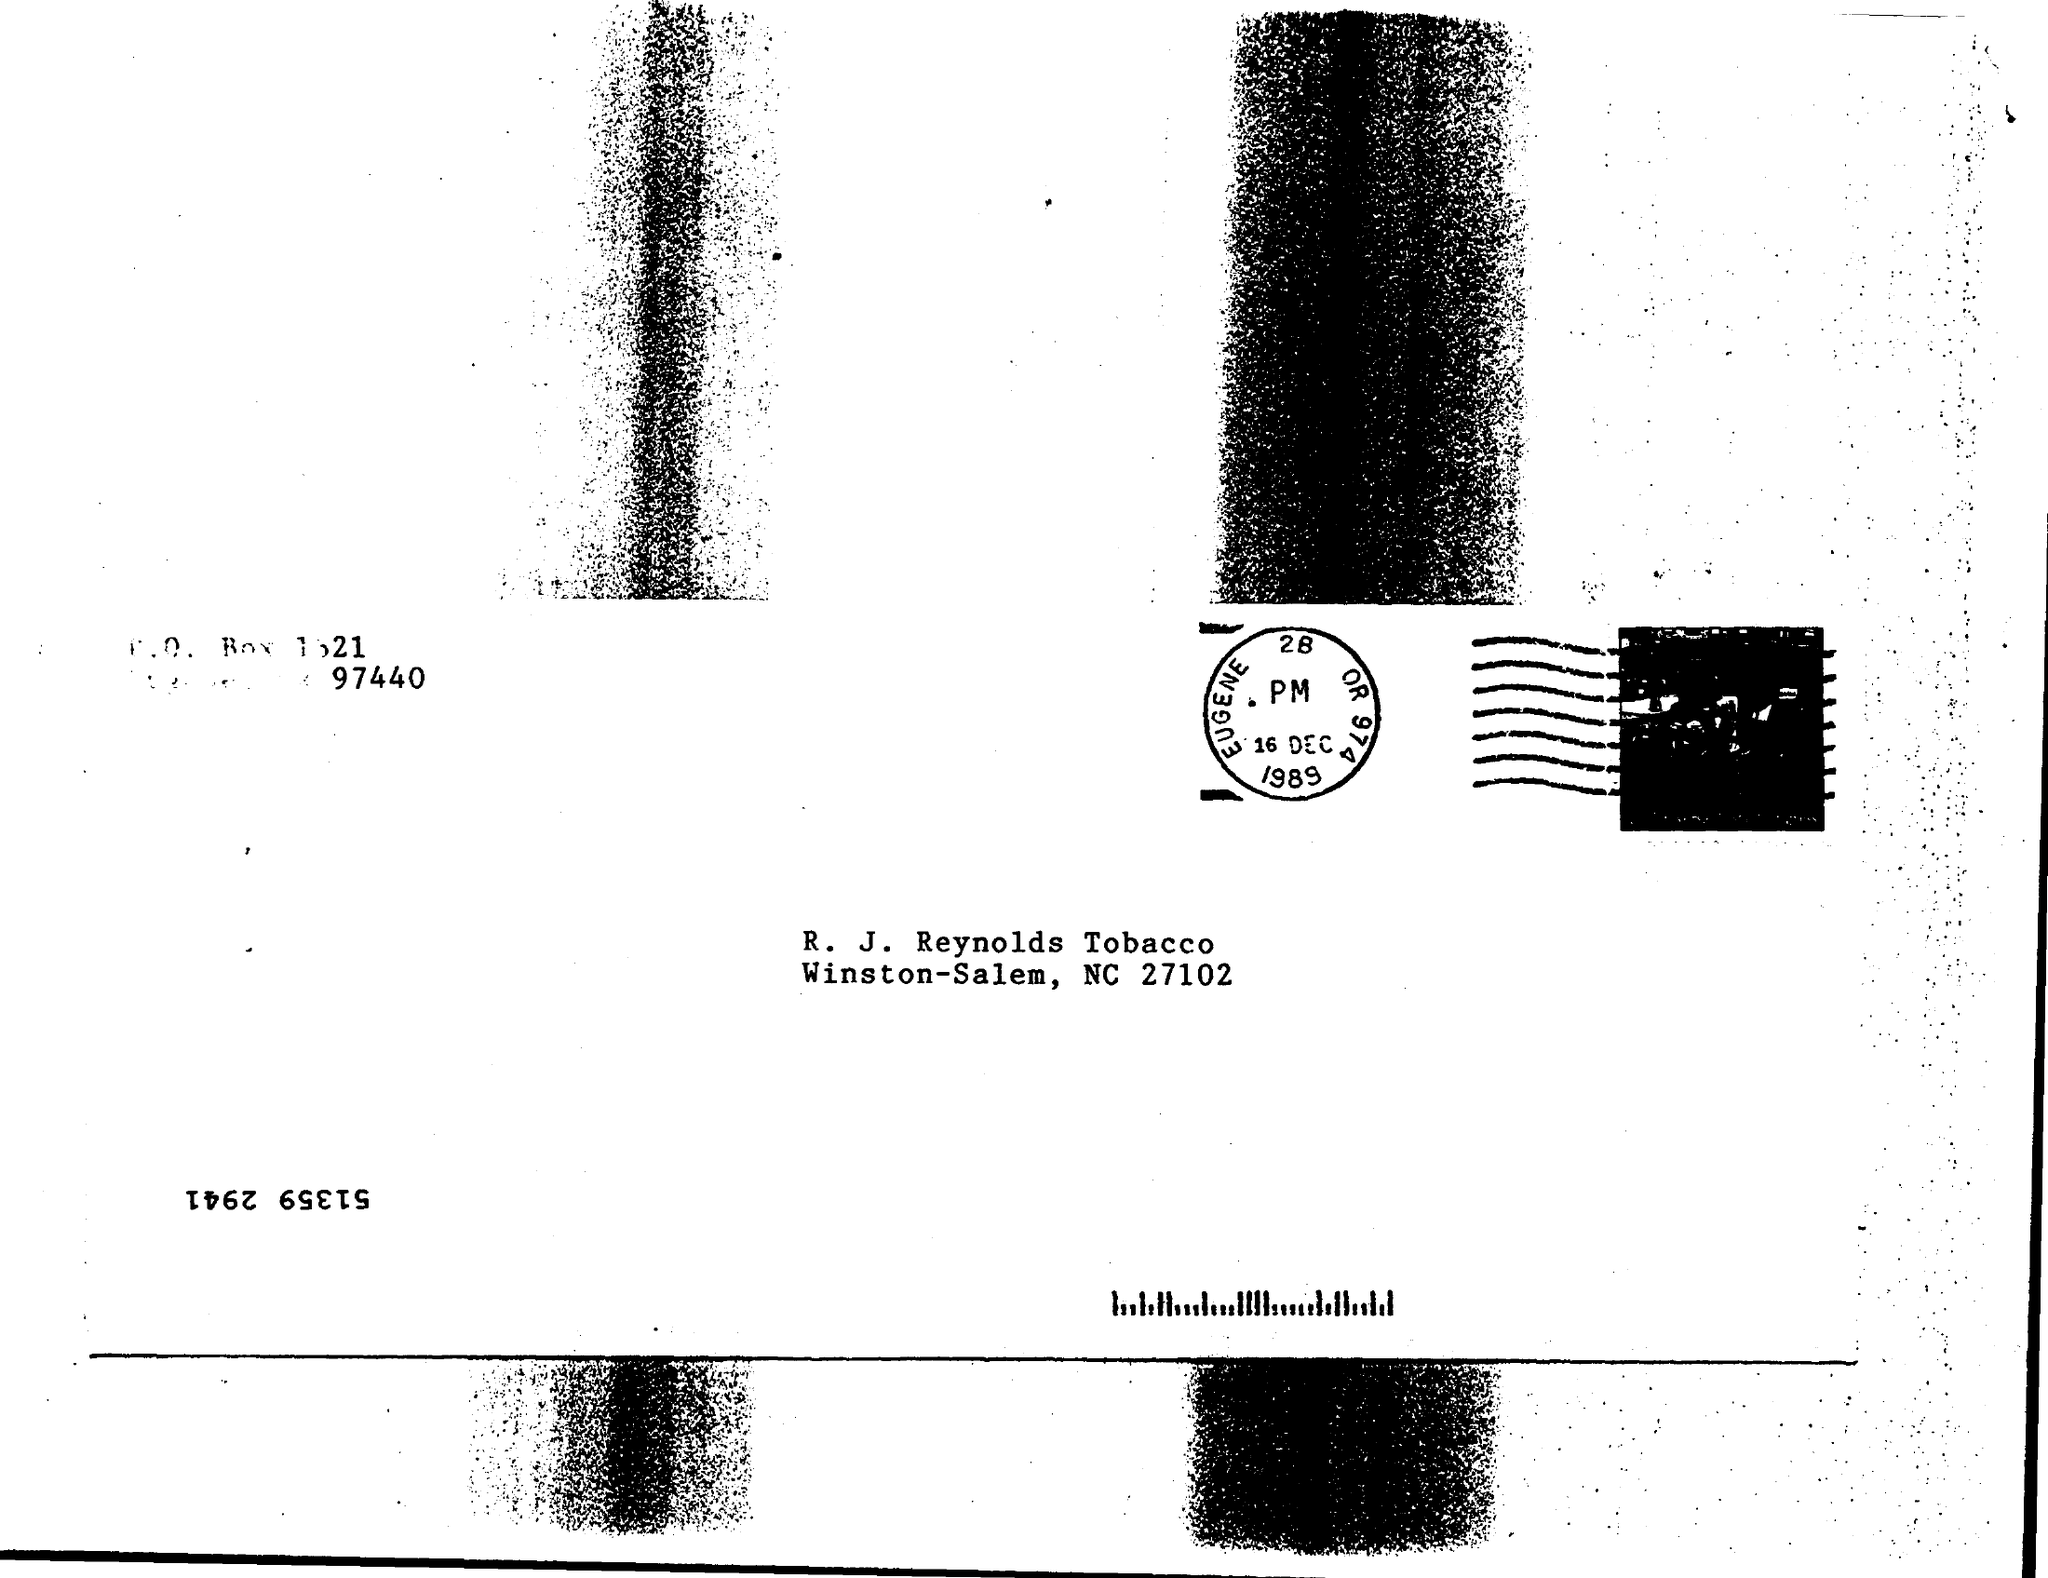What is the date on the stamp?
Your response must be concise. 16 Dec 1989. 